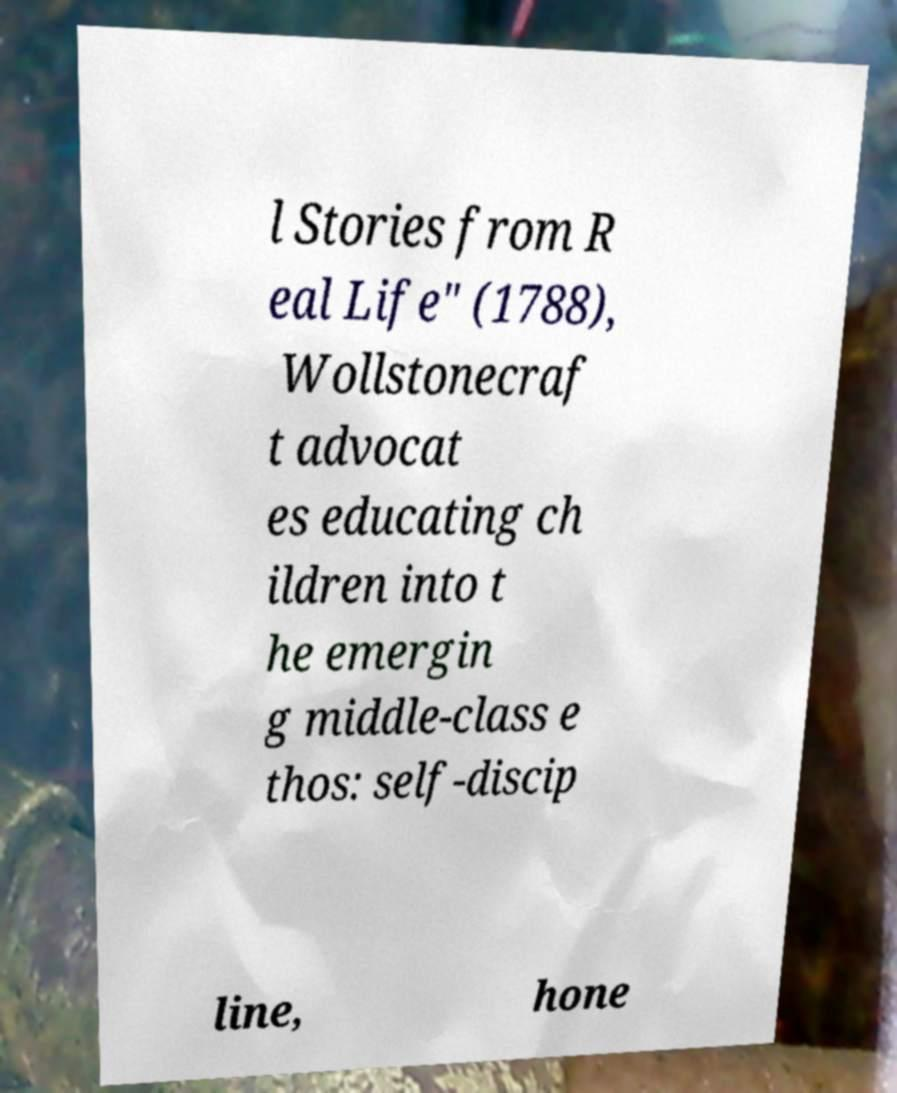Please read and relay the text visible in this image. What does it say? l Stories from R eal Life" (1788), Wollstonecraf t advocat es educating ch ildren into t he emergin g middle-class e thos: self-discip line, hone 